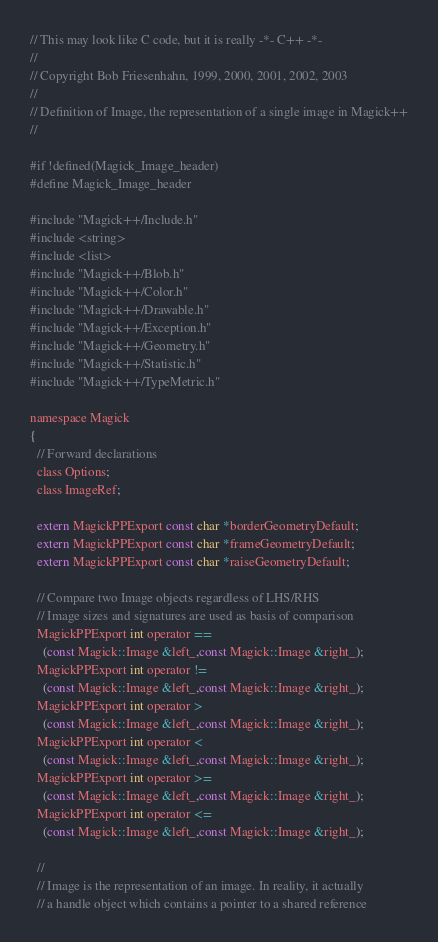Convert code to text. <code><loc_0><loc_0><loc_500><loc_500><_C_>// This may look like C code, but it is really -*- C++ -*-
//
// Copyright Bob Friesenhahn, 1999, 2000, 2001, 2002, 2003
//
// Definition of Image, the representation of a single image in Magick++
//

#if !defined(Magick_Image_header)
#define Magick_Image_header

#include "Magick++/Include.h"
#include <string>
#include <list>
#include "Magick++/Blob.h"
#include "Magick++/Color.h"
#include "Magick++/Drawable.h"
#include "Magick++/Exception.h"
#include "Magick++/Geometry.h"
#include "Magick++/Statistic.h"
#include "Magick++/TypeMetric.h"

namespace Magick
{
  // Forward declarations
  class Options;
  class ImageRef;

  extern MagickPPExport const char *borderGeometryDefault;
  extern MagickPPExport const char *frameGeometryDefault;
  extern MagickPPExport const char *raiseGeometryDefault;

  // Compare two Image objects regardless of LHS/RHS
  // Image sizes and signatures are used as basis of comparison
  MagickPPExport int operator ==
    (const Magick::Image &left_,const Magick::Image &right_);
  MagickPPExport int operator !=
    (const Magick::Image &left_,const Magick::Image &right_);
  MagickPPExport int operator >
    (const Magick::Image &left_,const Magick::Image &right_);
  MagickPPExport int operator <
    (const Magick::Image &left_,const Magick::Image &right_);
  MagickPPExport int operator >=
    (const Magick::Image &left_,const Magick::Image &right_);
  MagickPPExport int operator <=
    (const Magick::Image &left_,const Magick::Image &right_);

  //
  // Image is the representation of an image. In reality, it actually
  // a handle object which contains a pointer to a shared reference</code> 